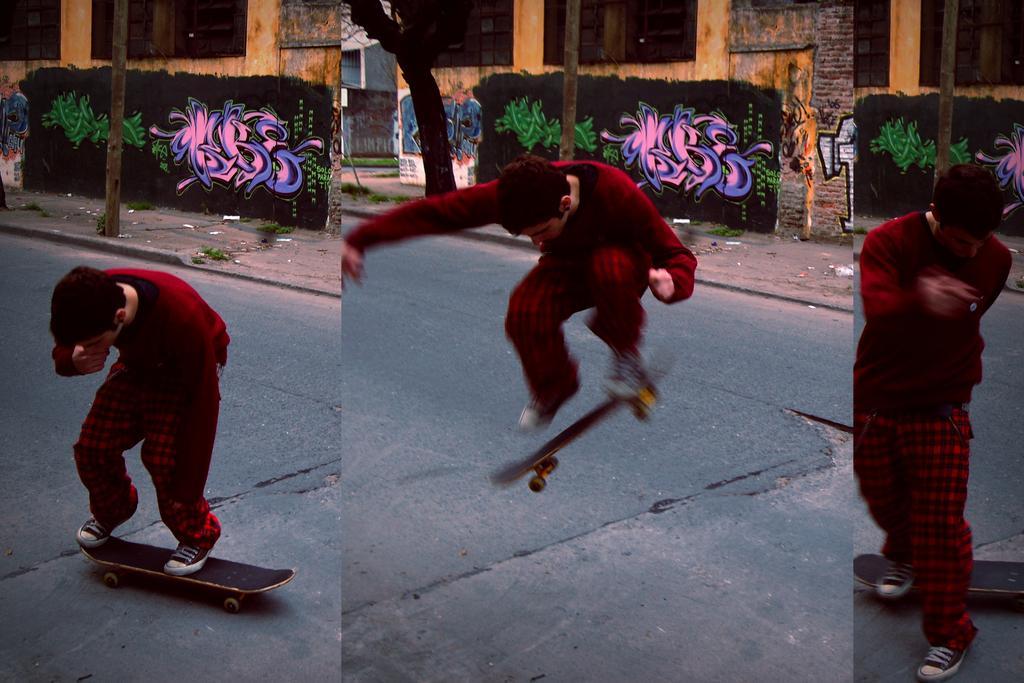How would you summarize this image in a sentence or two? This is a collage picture. I can see a person in different angles, doing skating with a skateboard on the road, and in the background there are houses, there is graffiti on the wall of a building, there is a tree and a pole. 